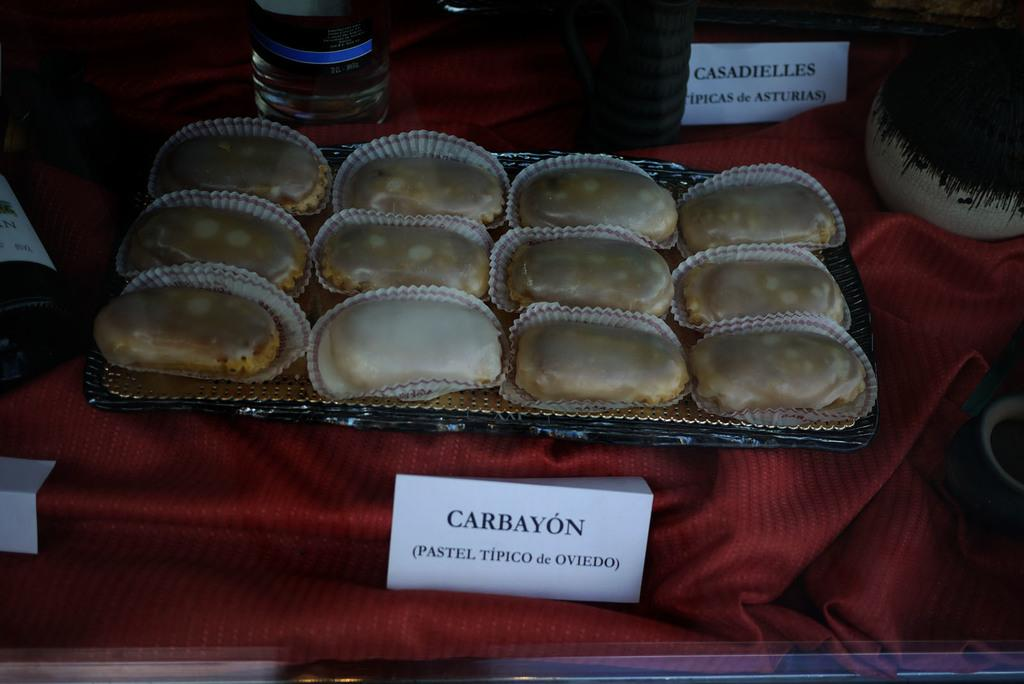What color is the cloth in the image? The cloth in the image is red. What is placed on the red cloth? There is a tray with sweets on the red cloth. What else can be seen in the image besides the red cloth and sweets? There are bottles and name tags in the image. What teaching method is being used in the image? There is no teaching method or classroom setting depicted in the image. 